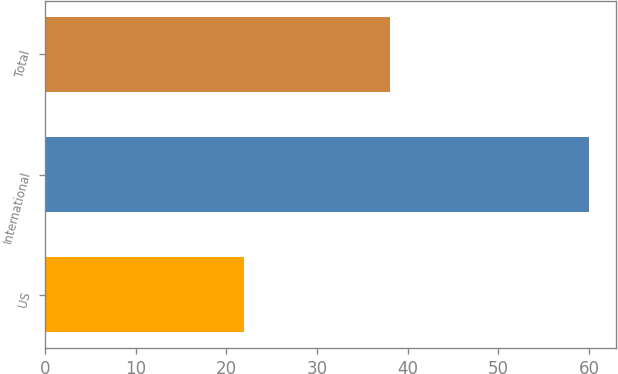Convert chart. <chart><loc_0><loc_0><loc_500><loc_500><bar_chart><fcel>US<fcel>International<fcel>Total<nl><fcel>22<fcel>60<fcel>38<nl></chart> 